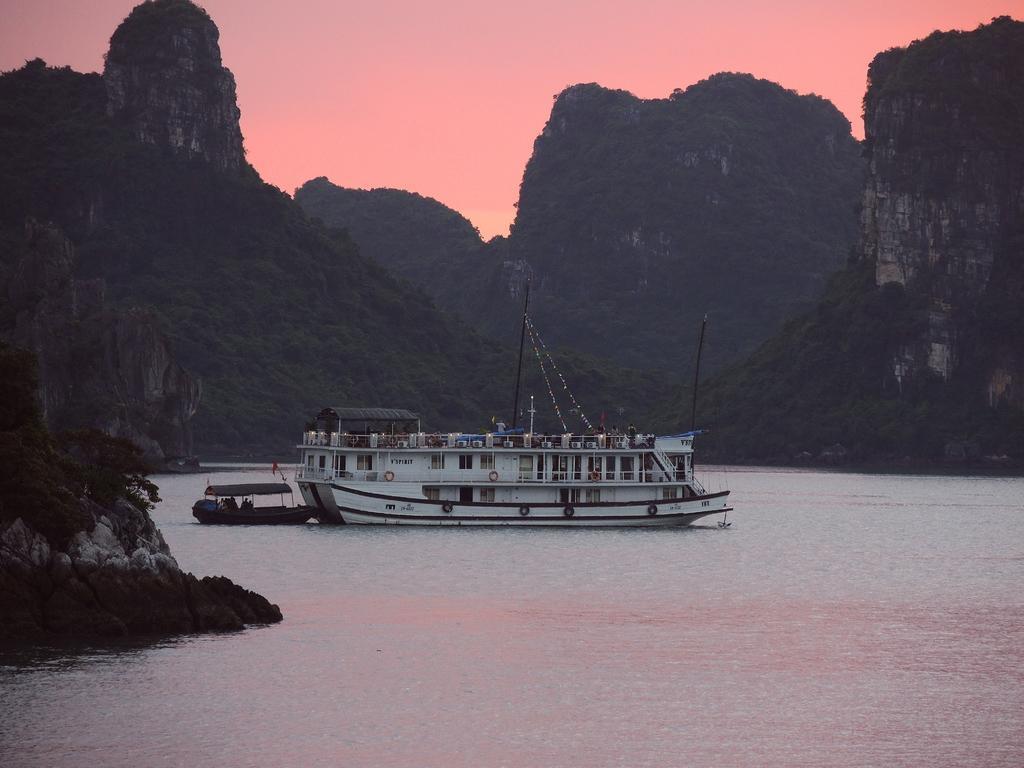In one or two sentences, can you explain what this image depicts? In this image I can see water and in it I can see two boats. I can also see orange colour in background and here on this boat I can see something is written. 